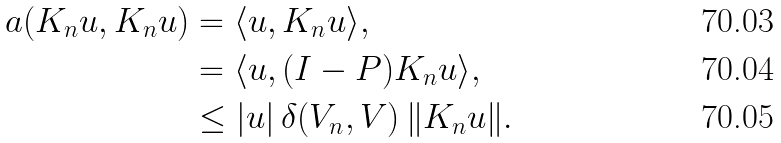<formula> <loc_0><loc_0><loc_500><loc_500>a ( K _ { n } u , K _ { n } u ) & = \langle u , K _ { n } u \rangle , \\ & = \langle u , ( I - P ) K _ { n } u \rangle , \\ & \leq | u | \, \delta ( V _ { n } , V ) \, \| K _ { n } u \| .</formula> 